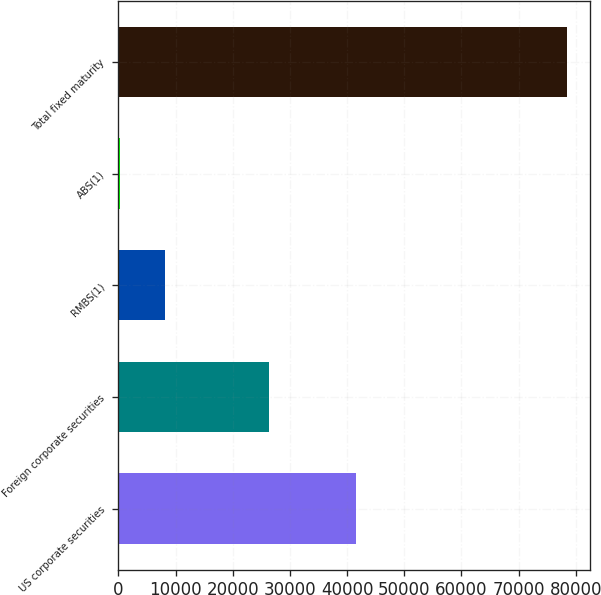Convert chart. <chart><loc_0><loc_0><loc_500><loc_500><bar_chart><fcel>US corporate securities<fcel>Foreign corporate securities<fcel>RMBS(1)<fcel>ABS(1)<fcel>Total fixed maturity<nl><fcel>41533<fcel>26383<fcel>8172.6<fcel>355<fcel>78531<nl></chart> 